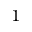<formula> <loc_0><loc_0><loc_500><loc_500>^ { 1 }</formula> 